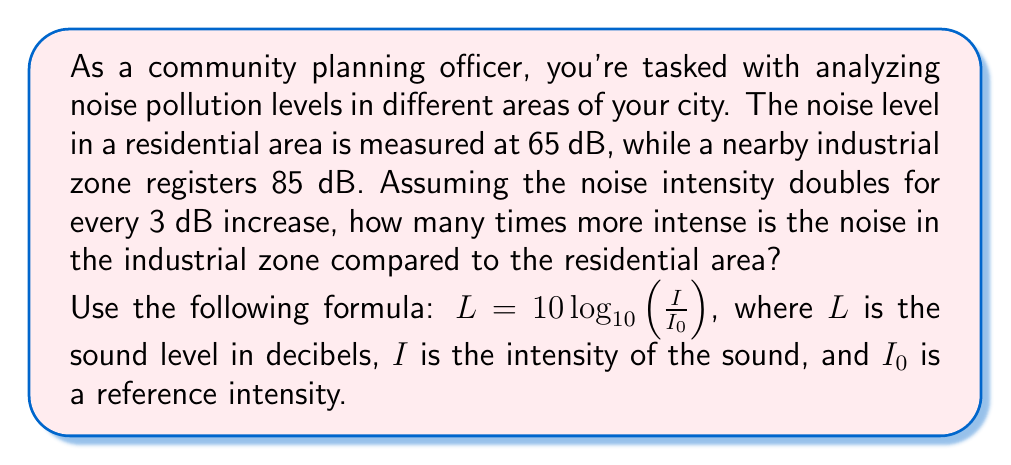Can you answer this question? Let's approach this problem step-by-step:

1) First, we need to understand the relationship between decibel increase and intensity increase. Given that the noise intensity doubles for every 3 dB increase, we can express this as:

   $2^n = \text{intensity ratio}$, where $n = \frac{\text{dB difference}}{3}$

2) Calculate the difference in decibels between the two areas:
   $85 \text{ dB} - 65 \text{ dB} = 20 \text{ dB}$

3) Calculate $n$:
   $n = \frac{20}{3} \approx 6.67$

4) Now we can calculate the intensity ratio:
   $\text{intensity ratio} = 2^{6.67}$

5) Using a calculator:
   $2^{6.67} \approx 101.59$

Therefore, the noise in the industrial zone is approximately 101.59 times more intense than in the residential area.

Alternatively, we could have used the logarithm formula directly:

$L_2 - L_1 = 10 \log_{10}\left(\frac{I_2}{I_1}\right)$

$20 = 10 \log_{10}\left(\frac{I_2}{I_1}\right)$

$2 = \log_{10}\left(\frac{I_2}{I_1}\right)$

$10^2 = \frac{I_2}{I_1}$

$100 = \frac{I_2}{I_1}$

This gives us a similar result (the small difference is due to rounding in the first method).
Answer: The noise in the industrial zone is approximately 101.59 times more intense than in the residential area. 